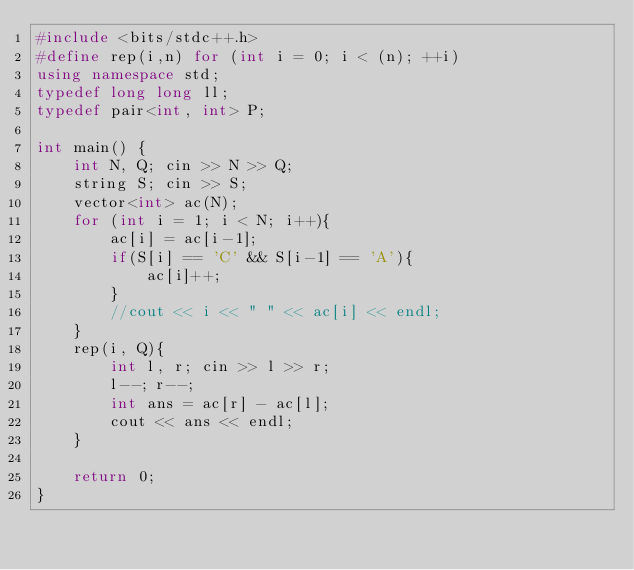<code> <loc_0><loc_0><loc_500><loc_500><_C++_>#include <bits/stdc++.h>
#define rep(i,n) for (int i = 0; i < (n); ++i)
using namespace std;
typedef long long ll;
typedef pair<int, int> P;

int main() {
    int N, Q; cin >> N >> Q;
    string S; cin >> S;
    vector<int> ac(N);
    for (int i = 1; i < N; i++){
        ac[i] = ac[i-1];
        if(S[i] == 'C' && S[i-1] == 'A'){
            ac[i]++;
        }
        //cout << i << " " << ac[i] << endl;
    }
    rep(i, Q){
        int l, r; cin >> l >> r;
        l--; r--;
        int ans = ac[r] - ac[l];
        cout << ans << endl;
    }

    return 0;
}</code> 